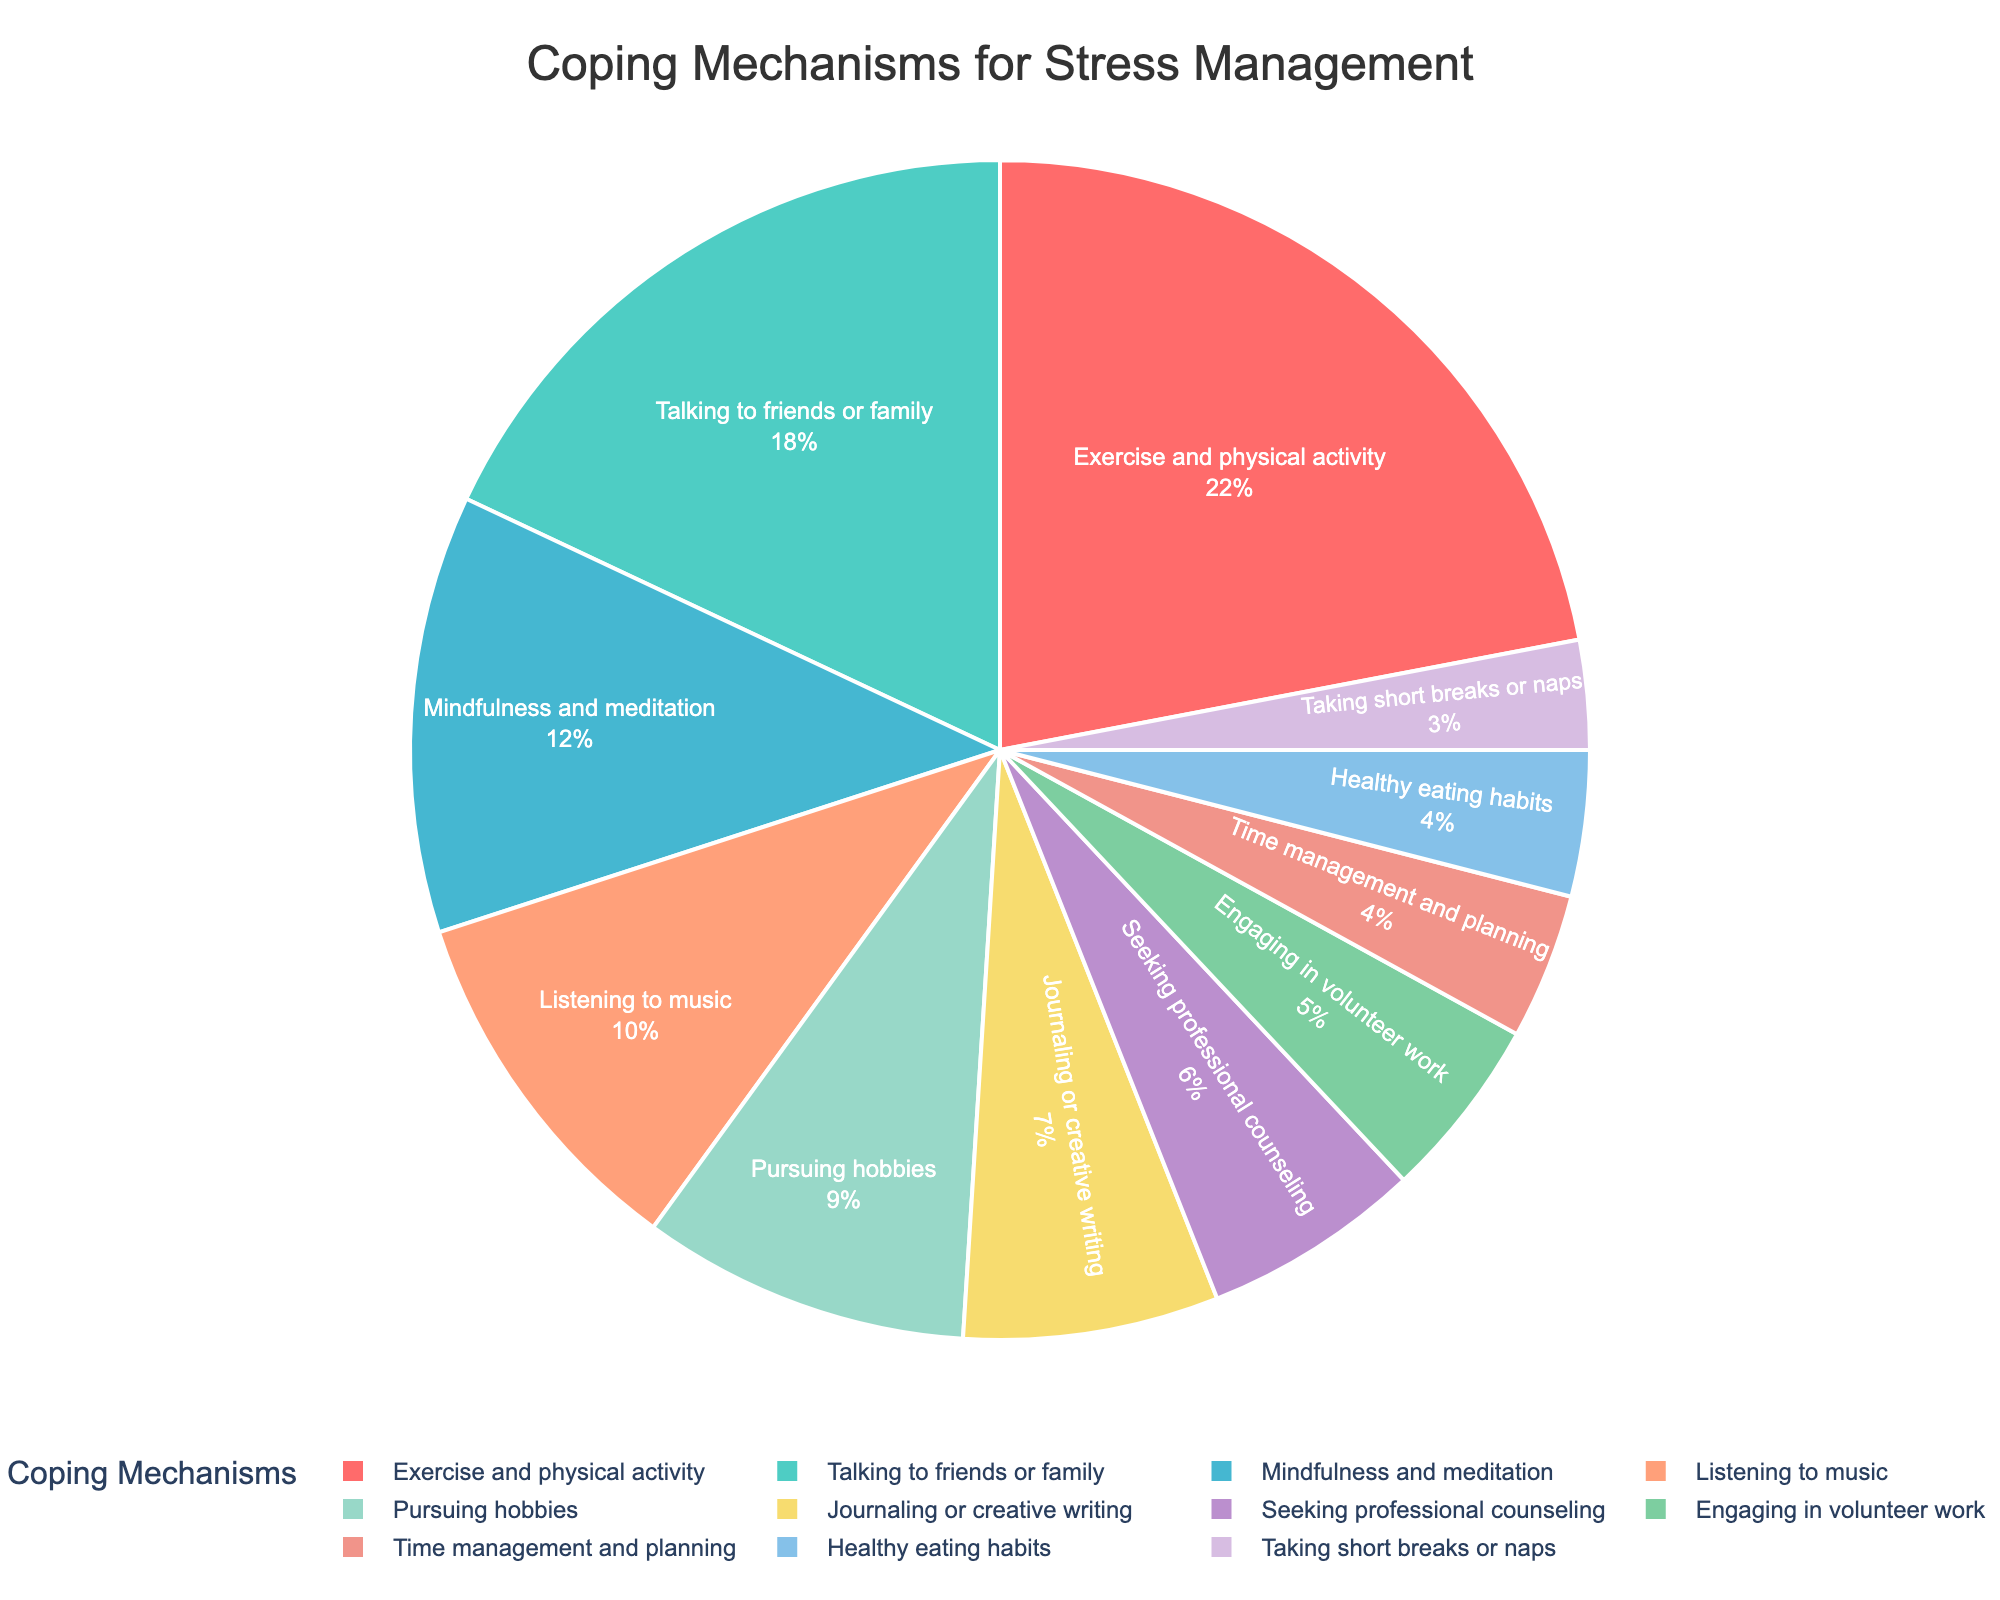Which coping mechanism has the highest percentage? The coping mechanism with the highest percentage can be identified by looking for the largest segment in the pie chart.
Answer: Exercise and physical activity What is the combined percentage of mindfulness and meditation, and listening to music? Add the percentages of mindfulness and meditation (12%) and listening to music (10%). 12 + 10 = 22.
Answer: 22 Which mechanisms have a percentage less than 10? Identify the segments with percentages less than 10. These are pursuing hobbies (9%), journaling or creative writing (7%), seeking professional counseling (6%), engaging in volunteer work (5%), time management and planning (4%), healthy eating habits (4%), and taking short breaks or naps (3%).
Answer: Pursuing hobbies, journaling or creative writing, seeking professional counseling, engaging in volunteer work, time management and planning, healthy eating habits, taking short breaks or naps How much more popular is talking to friends or family compared to seeking professional counseling? Subtract the percentage of seeking professional counseling (6%) from talking to friends or family (18%). 18 - 6 = 12.
Answer: 12 What is the sum of the percentages for exercise and physical activity, and engaging in volunteer work? Add the percentages of exercise and physical activity (22%) and engaging in volunteer work (5%). 22 + 5 = 27.
Answer: 27 Which coping mechanism is represented by the purple color? Locate the segment with the purple color in the pie chart and identify the corresponding coping mechanism.
Answer: Journaling or creative writing Is mindfulness and meditation usage higher or lower than listening to music? Compare the percentages of mindfulness and meditation (12%) and listening to music (10%). Since 12% > 10%, mindfulness and meditation usage is higher.
Answer: Higher What is the collective percentage of those using time management and planning, and healthy eating habits as coping mechanisms? Add the percentage values of time management and planning (4%) and healthy eating habits (4%). 4 + 4 = 8.
Answer: 8 Between pursuing hobbies and taking short breaks or naps, which is more popular and by how much? Subtract the percentage of taking short breaks or naps (3%) from pursuing hobbies (9%). 9 - 3 = 6. Pursuing hobbies is more popular by 6%.
Answer: Pursuing hobbies by 6 